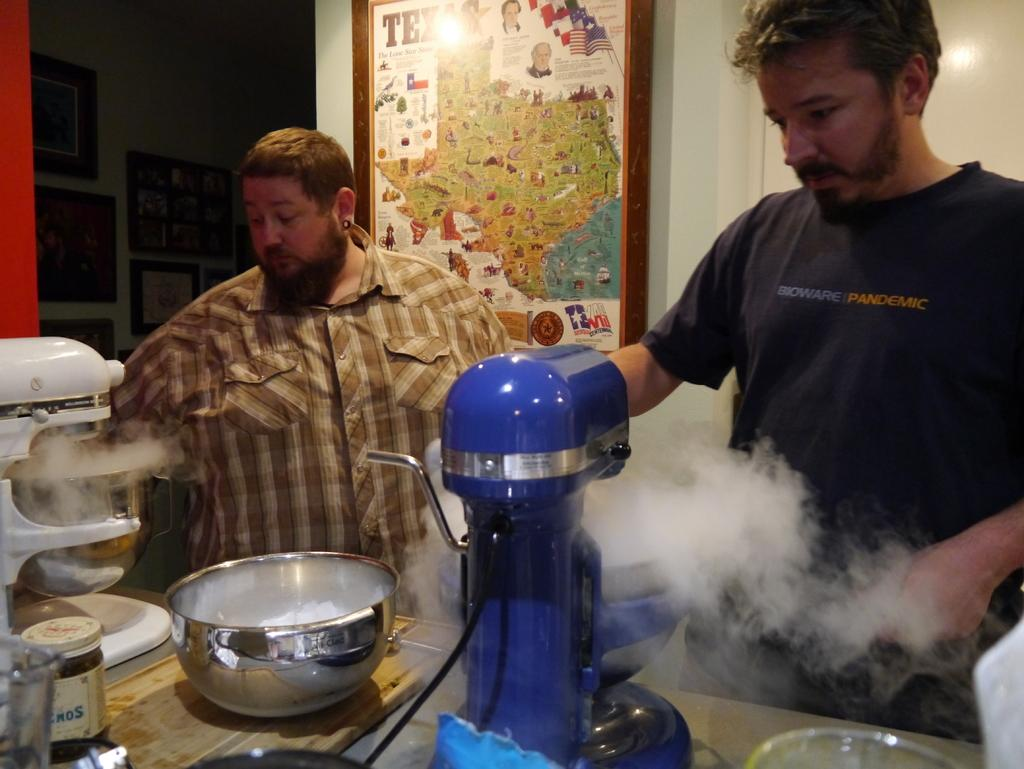Provide a one-sentence caption for the provided image. A man wearing a tshirt that says Bioware Pandemic prepares food with another man in a plaid shirt who is standing in front of  a Texas map. 